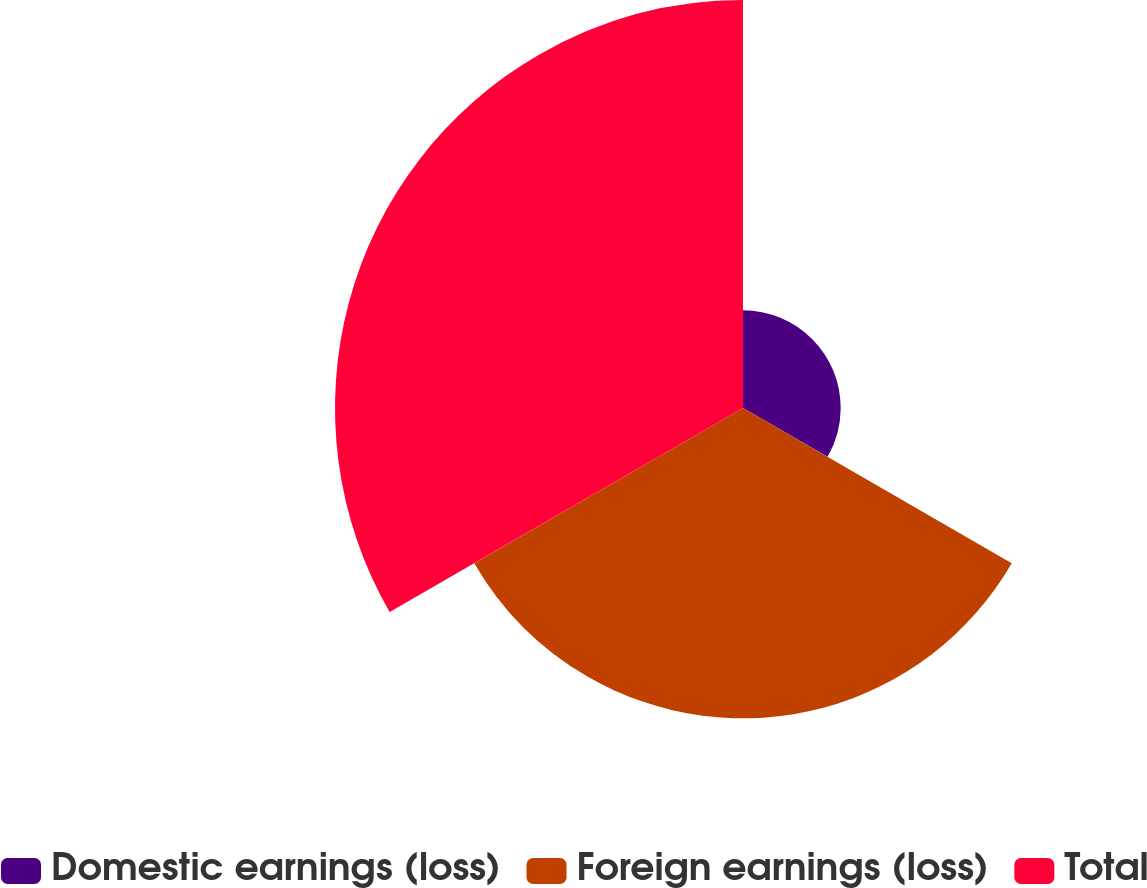Convert chart to OTSL. <chart><loc_0><loc_0><loc_500><loc_500><pie_chart><fcel>Domestic earnings (loss)<fcel>Foreign earnings (loss)<fcel>Total<nl><fcel>11.97%<fcel>38.03%<fcel>50.0%<nl></chart> 